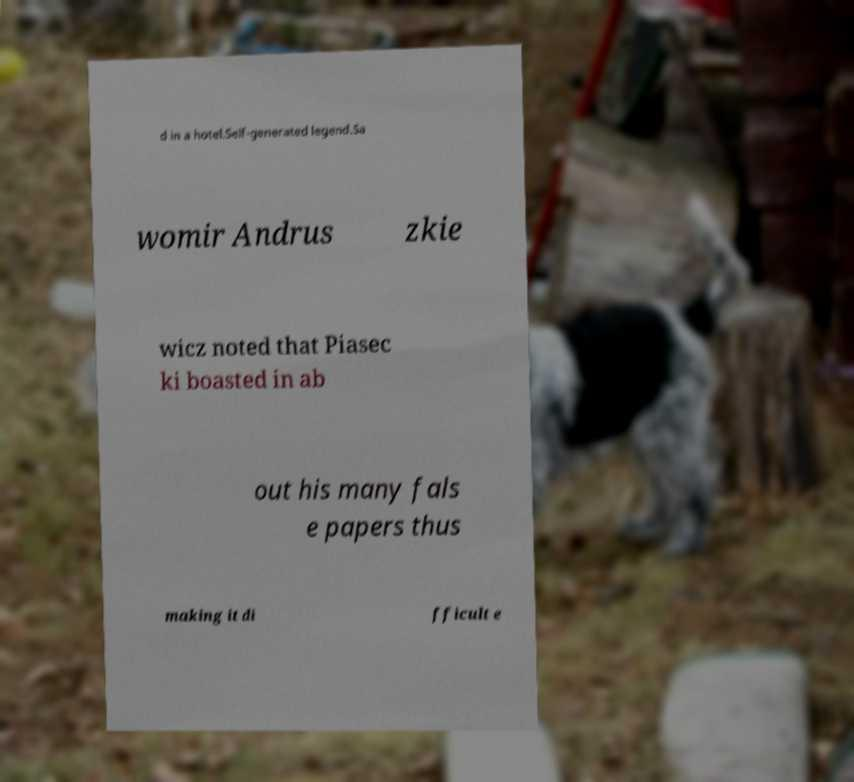Could you extract and type out the text from this image? d in a hotel.Self-generated legend.Sa womir Andrus zkie wicz noted that Piasec ki boasted in ab out his many fals e papers thus making it di fficult e 